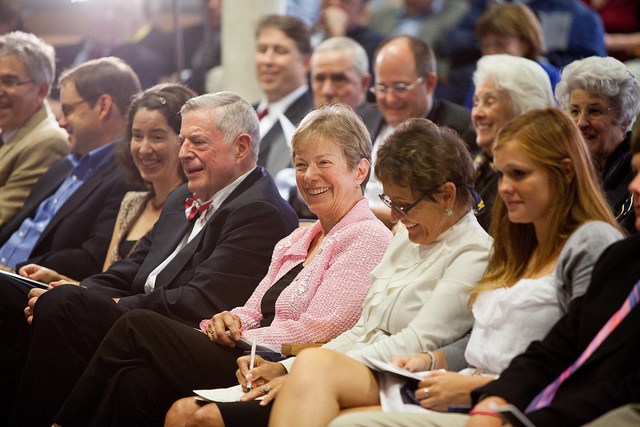<image>Where are the people in the photograph? It is ambiguous where the people in the photograph are. They could either be in a church or a conference hall. Where are the people in the photograph? It is unclear where the people in the photograph are. They can be seen in a church, science lab, meeting room, seminar, or conference hall. 